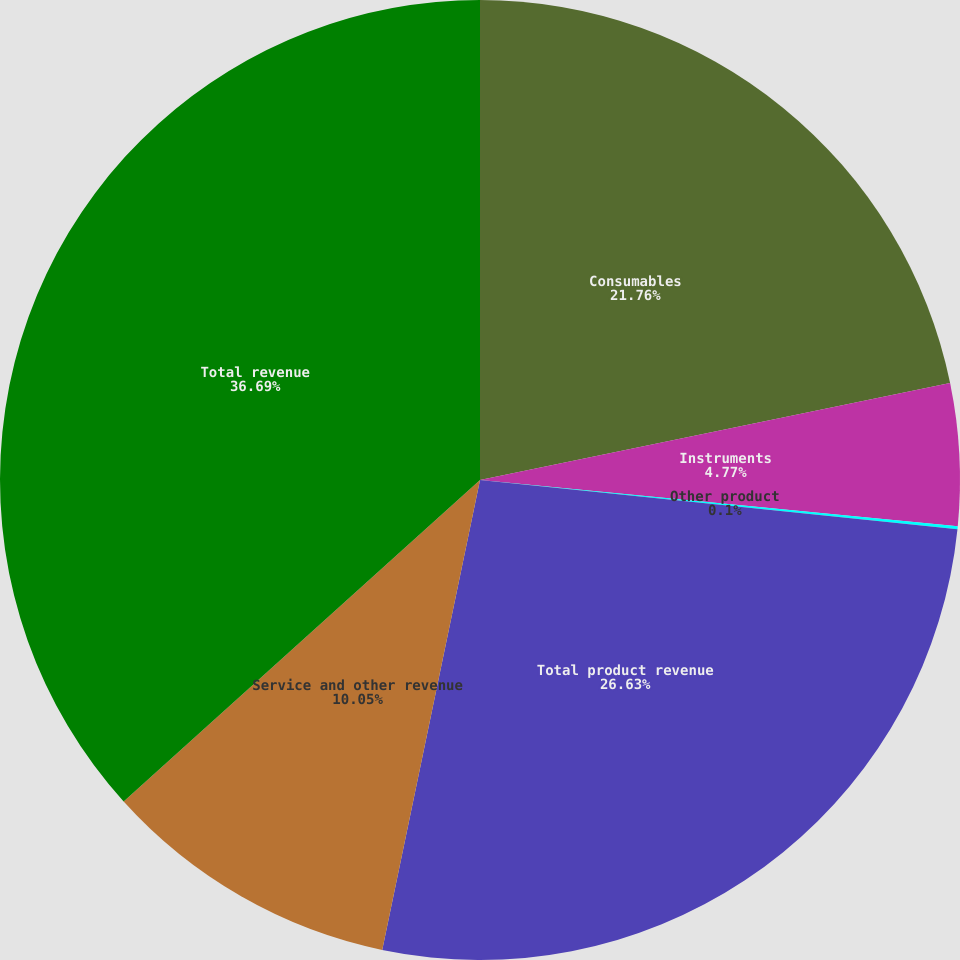Convert chart. <chart><loc_0><loc_0><loc_500><loc_500><pie_chart><fcel>Consumables<fcel>Instruments<fcel>Other product<fcel>Total product revenue<fcel>Service and other revenue<fcel>Total revenue<nl><fcel>21.76%<fcel>4.77%<fcel>0.1%<fcel>26.63%<fcel>10.05%<fcel>36.68%<nl></chart> 